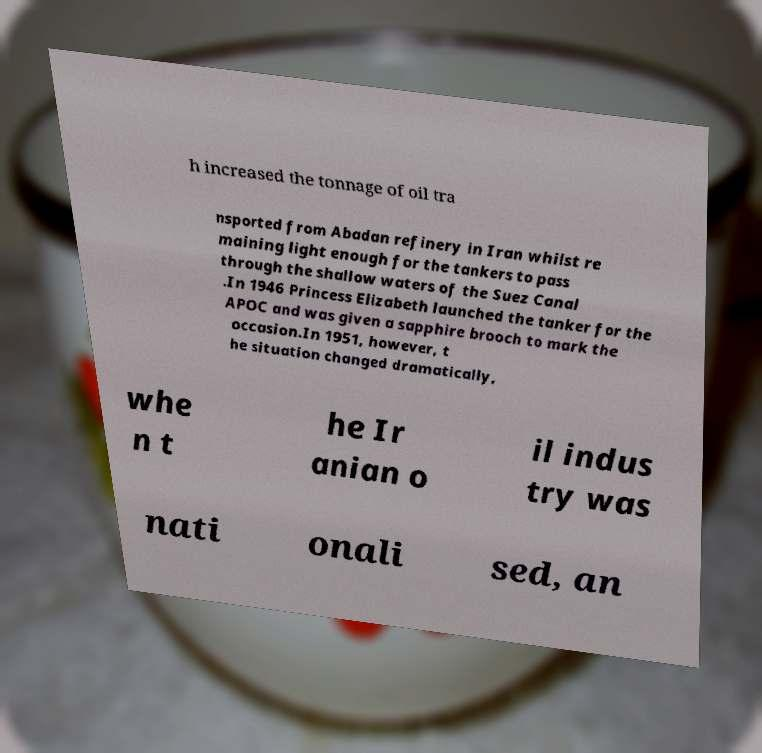There's text embedded in this image that I need extracted. Can you transcribe it verbatim? h increased the tonnage of oil tra nsported from Abadan refinery in Iran whilst re maining light enough for the tankers to pass through the shallow waters of the Suez Canal .In 1946 Princess Elizabeth launched the tanker for the APOC and was given a sapphire brooch to mark the occasion.In 1951, however, t he situation changed dramatically, whe n t he Ir anian o il indus try was nati onali sed, an 